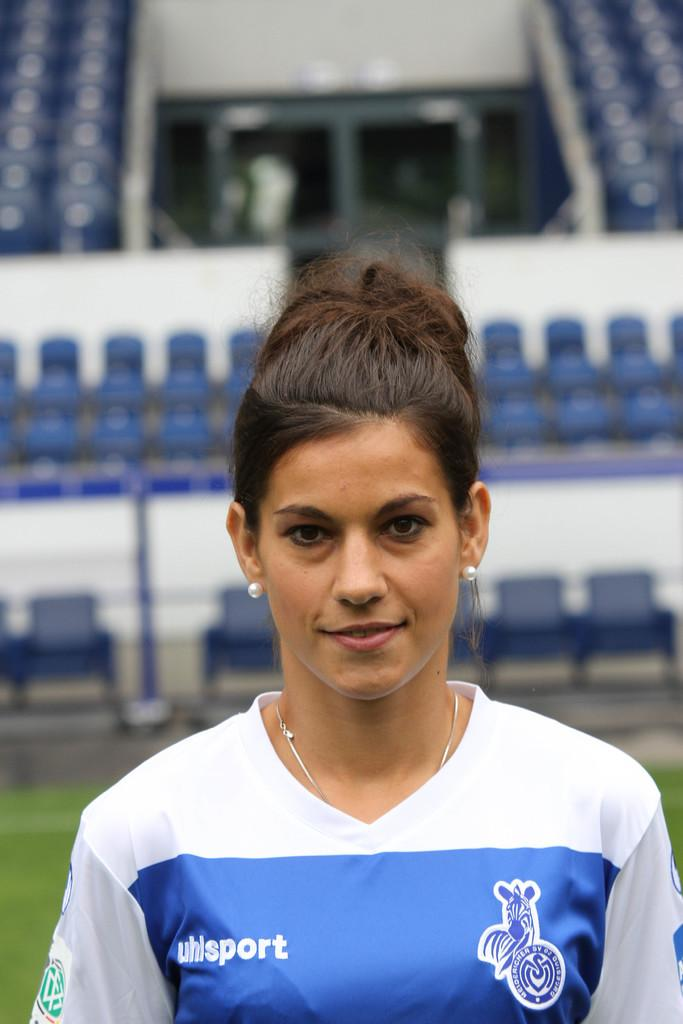Provide a one-sentence caption for the provided image. A woman with a blue and white shirt that says uhlsport stands in front of stadium seating. 